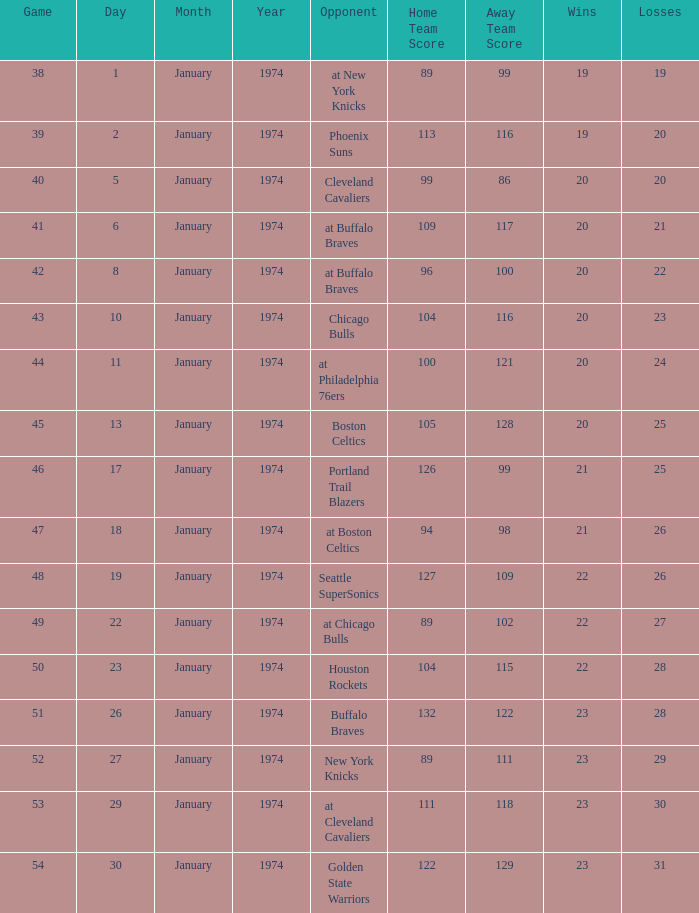What was the score on 1/10/1974? 104 - 116. 